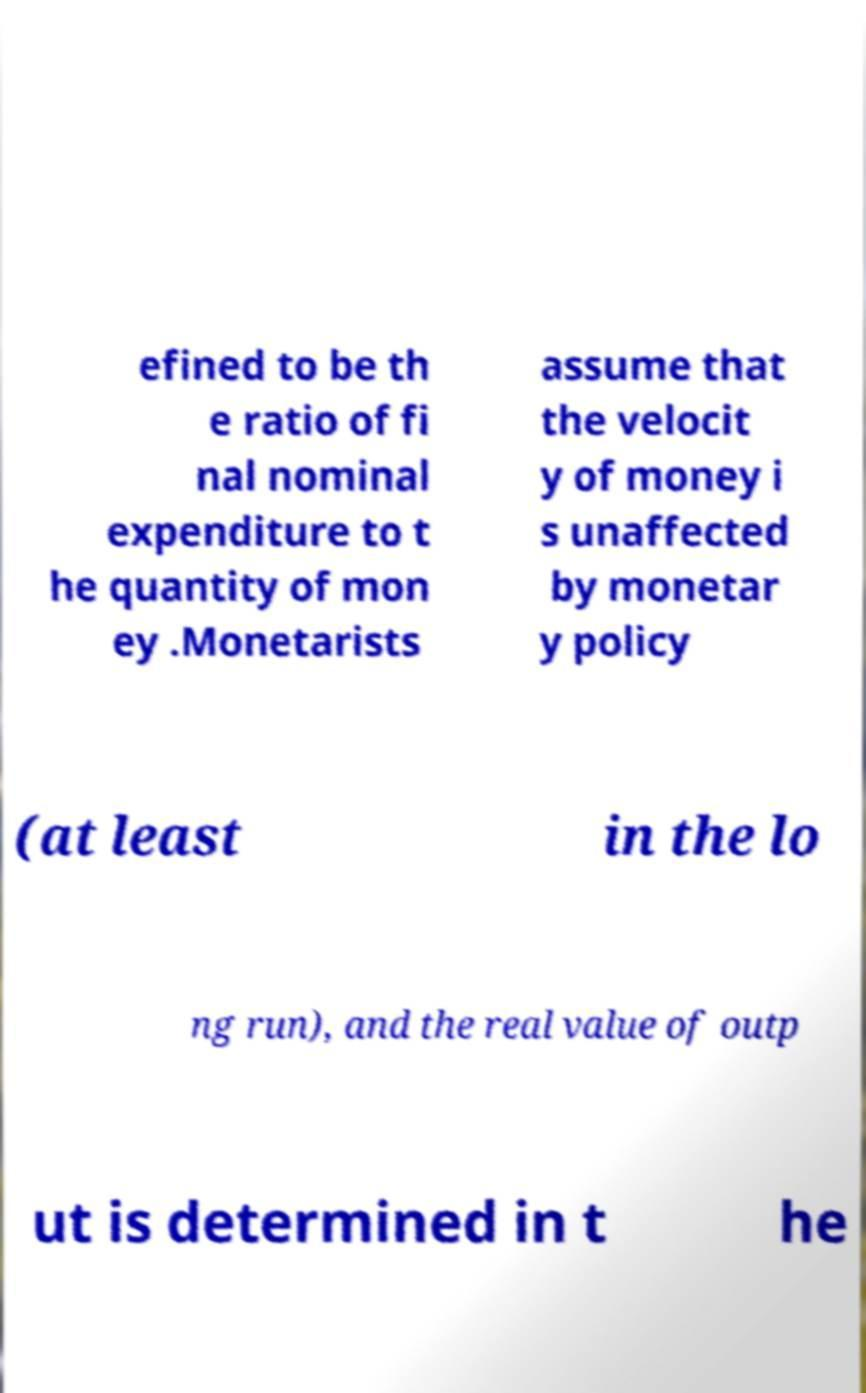What messages or text are displayed in this image? I need them in a readable, typed format. efined to be th e ratio of fi nal nominal expenditure to t he quantity of mon ey .Monetarists assume that the velocit y of money i s unaffected by monetar y policy (at least in the lo ng run), and the real value of outp ut is determined in t he 